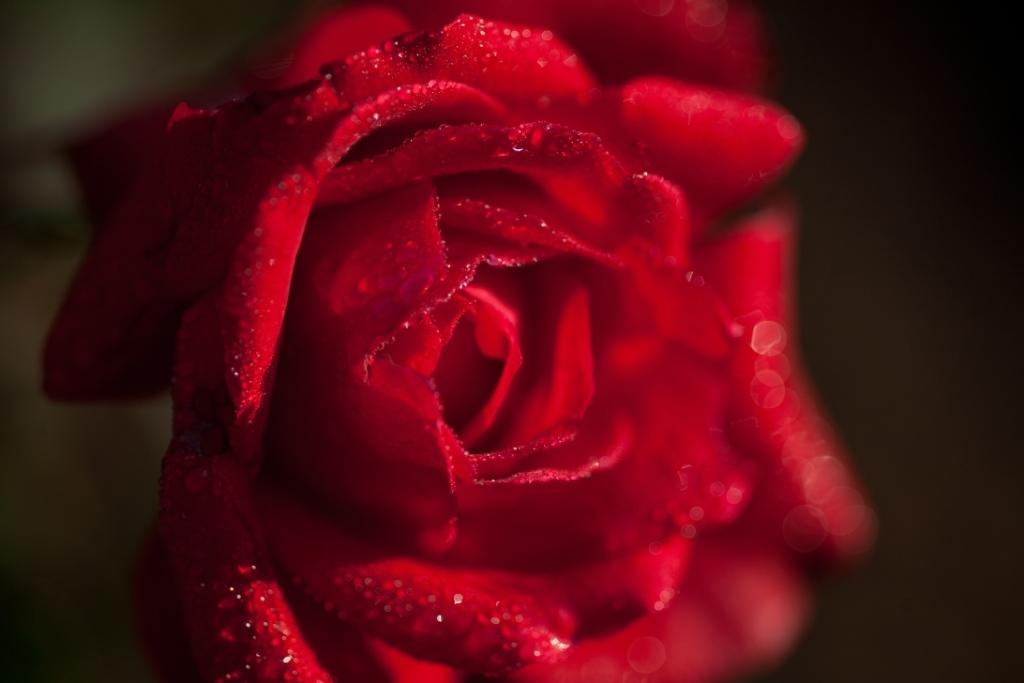What type of flower is in the image? There is a rose flower in the image. Can you see any worms crawling on the rose flower in the image? There are no worms present in the image; it only features a rose flower. 